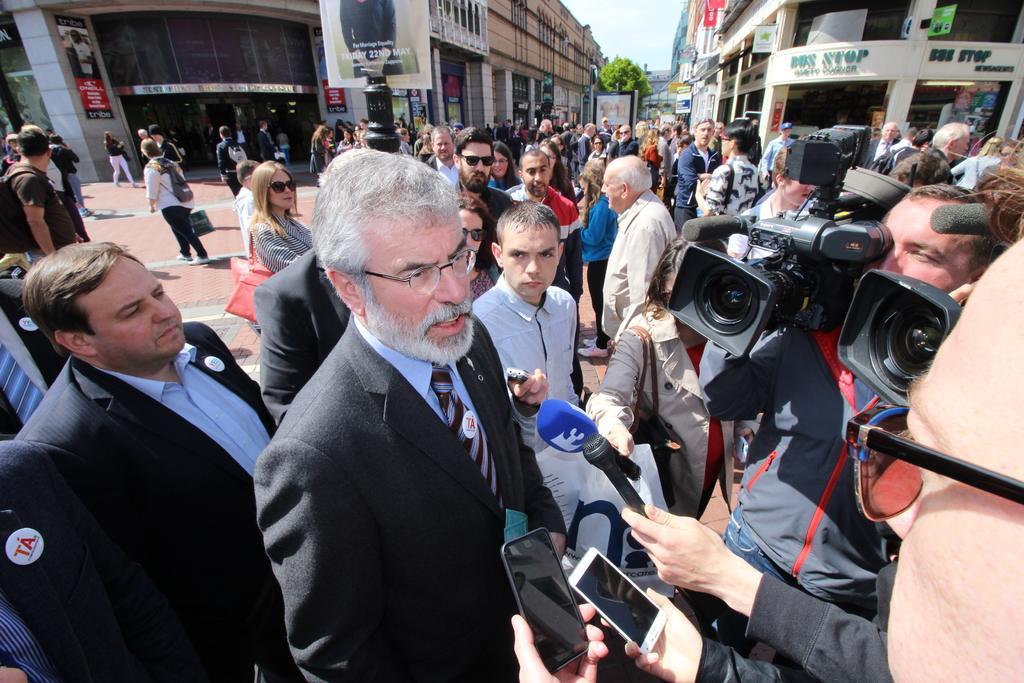In one or two sentences, can you explain what this image depicts? In the picture we can see some media people are taking an interview of a man holding the microphones and cameras and a man is in blazer, tie and shirt and behind him we can see two other men in the blazers and beside them, we can see some people are standing and behind them we can see the buildings, tree and a part of the sky. 